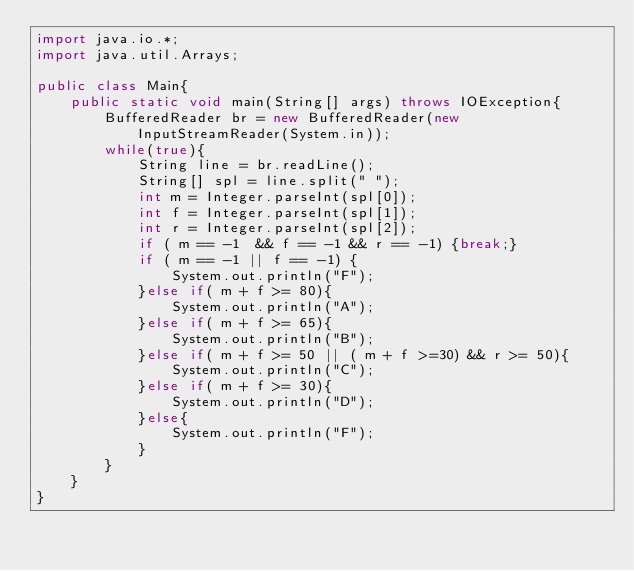Convert code to text. <code><loc_0><loc_0><loc_500><loc_500><_Java_>import java.io.*;
import java.util.Arrays;
 
public class Main{
    public static void main(String[] args) throws IOException{ 
        BufferedReader br = new BufferedReader(new InputStreamReader(System.in));
        while(true){
            String line = br.readLine();
            String[] spl = line.split(" ");
            int m = Integer.parseInt(spl[0]);
            int f = Integer.parseInt(spl[1]);
            int r = Integer.parseInt(spl[2]);
            if ( m == -1  && f == -1 && r == -1) {break;}
            if ( m == -1 || f == -1) {
                System.out.println("F");
            }else if( m + f >= 80){
                System.out.println("A");
            }else if( m + f >= 65){
                System.out.println("B");
            }else if( m + f >= 50 || ( m + f >=30) && r >= 50){
                System.out.println("C");
            }else if( m + f >= 30){
                System.out.println("D");
            }else{
                System.out.println("F");
            }
        }
    }
}</code> 